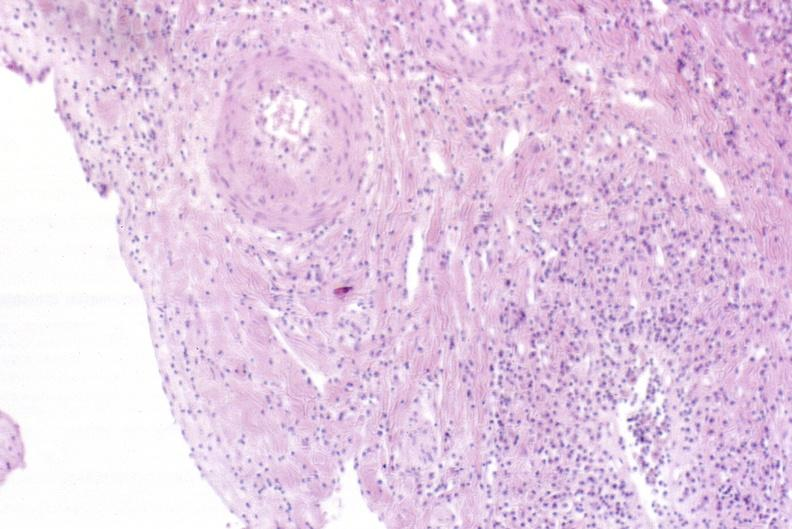s hepatobiliary present?
Answer the question using a single word or phrase. Yes 